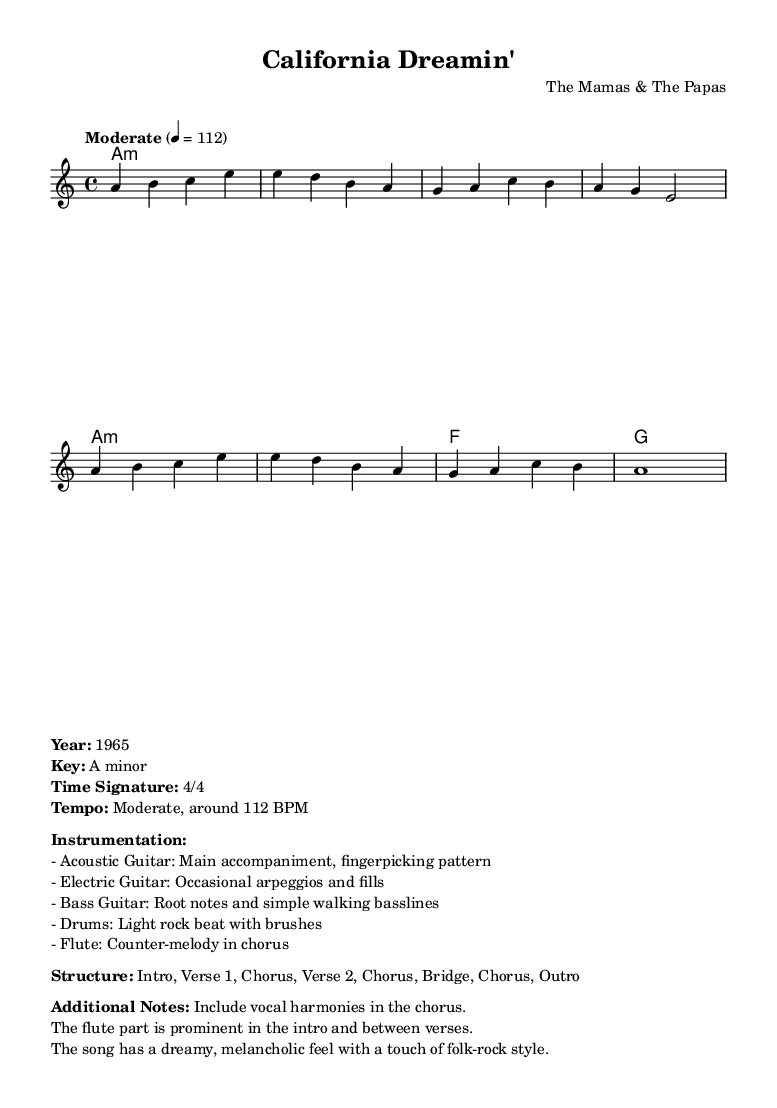What is the title of this piece? The title of the piece can be found in the header section of the sheet music. It is usually prominently displayed.
Answer: California Dreamin' What is the key signature of this music? The key signature is indicated in the global variable setting in the music sheet code. It specifies the key of A minor, which is characterized by the absence of sharps or flats.
Answer: A minor What is the time signature of this music? The time signature is also found in the global variable section of the sheet music. It is written as 4/4, meaning there are four beats per measure and the quarter note gets one beat.
Answer: 4/4 What is the tempo marking for this piece? The tempo marking is indicated in the global section, which states "Moderate" and provides a specific BPM (beats per minute) value of 112. This gives performers a guideline for the speed of the music.
Answer: Moderate, 112 BPM How many verses are in the structure of the song? The structure of the song is detailed in the markup section, where it specifies "Intro, Verse 1, Chorus, Verse 2, Chorus, Bridge, Chorus, Outro." By counting the verses mentioned, we find that there are two verses.
Answer: 2 What instrumentation is noted for this piece? The instrumentation is listed in the markup section, outlining the various instruments used: Acoustic Guitar, Electric Guitar, Bass Guitar, Drums, and Flute. Each plays a specific role that contributes to the overall sound.
Answer: Acoustic Guitar, Electric Guitar, Bass Guitar, Drums, Flute What is the mood described for this piece? The mood is conveyed in the additional notes section of the markup. It describes the feel of the song as "dreamy, melancholic," which provides insight into the emotional quality musicians should convey while performing it.
Answer: Dreamy, melancholic 